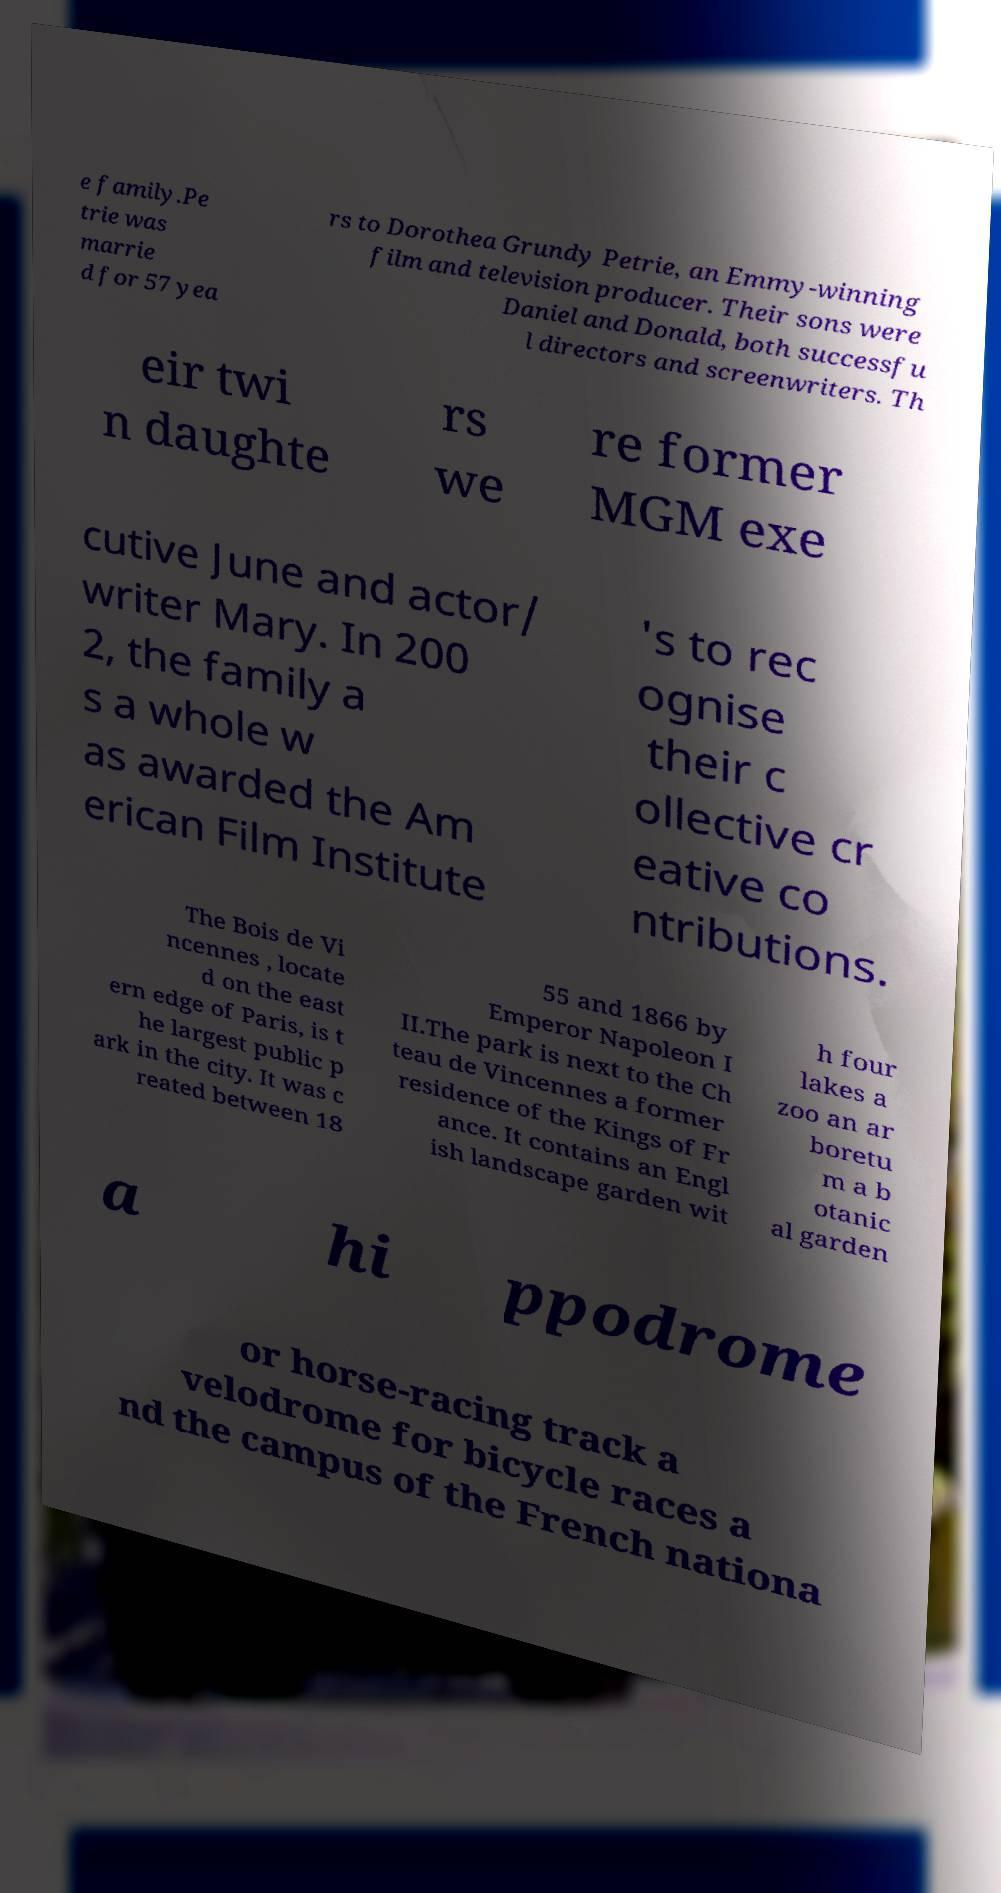Please read and relay the text visible in this image. What does it say? e family.Pe trie was marrie d for 57 yea rs to Dorothea Grundy Petrie, an Emmy-winning film and television producer. Their sons were Daniel and Donald, both successfu l directors and screenwriters. Th eir twi n daughte rs we re former MGM exe cutive June and actor/ writer Mary. In 200 2, the family a s a whole w as awarded the Am erican Film Institute 's to rec ognise their c ollective cr eative co ntributions. The Bois de Vi ncennes , locate d on the east ern edge of Paris, is t he largest public p ark in the city. It was c reated between 18 55 and 1866 by Emperor Napoleon I II.The park is next to the Ch teau de Vincennes a former residence of the Kings of Fr ance. It contains an Engl ish landscape garden wit h four lakes a zoo an ar boretu m a b otanic al garden a hi ppodrome or horse-racing track a velodrome for bicycle races a nd the campus of the French nationa 